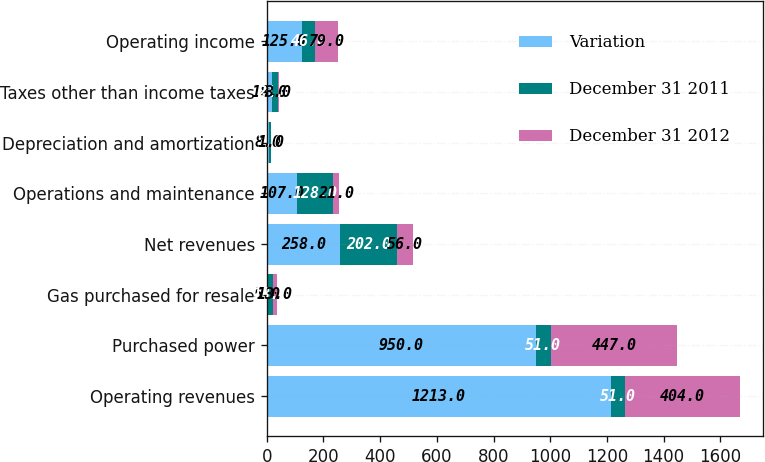<chart> <loc_0><loc_0><loc_500><loc_500><stacked_bar_chart><ecel><fcel>Operating revenues<fcel>Purchased power<fcel>Gas purchased for resale<fcel>Net revenues<fcel>Operations and maintenance<fcel>Depreciation and amortization<fcel>Taxes other than income taxes<fcel>Operating income<nl><fcel>Variation<fcel>1213<fcel>950<fcel>5<fcel>258<fcel>107<fcel>8<fcel>18<fcel>125<nl><fcel>December 31 2011<fcel>51<fcel>51<fcel>18<fcel>202<fcel>128<fcel>7<fcel>21<fcel>46<nl><fcel>December 31 2012<fcel>404<fcel>447<fcel>13<fcel>56<fcel>21<fcel>1<fcel>3<fcel>79<nl></chart> 